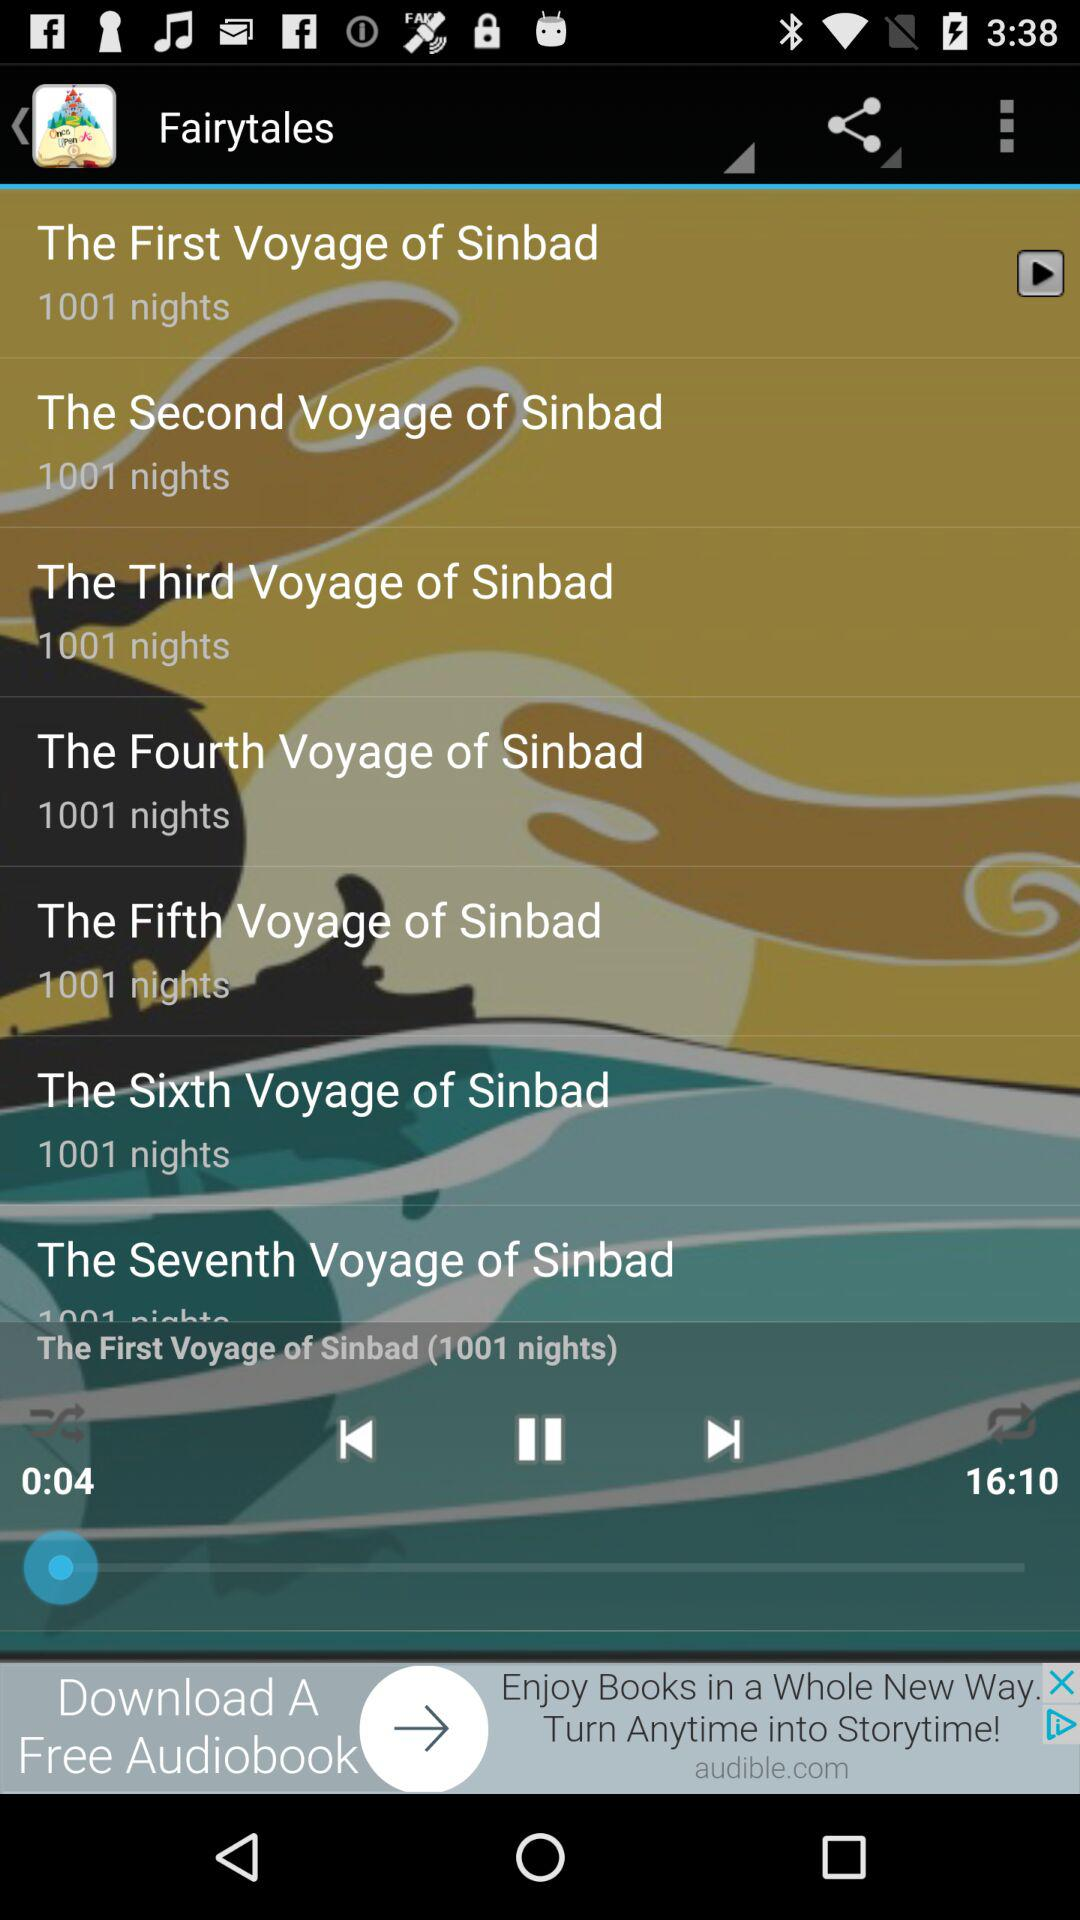Which audio is playing? The currently playing audio is "The First Voyage of Sinbad (1001 nights)". 